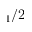<formula> <loc_0><loc_0><loc_500><loc_500>_ { 1 } / 2</formula> 